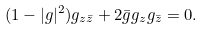Convert formula to latex. <formula><loc_0><loc_0><loc_500><loc_500>( 1 - | g | ^ { 2 } ) g _ { z \bar { z } } + 2 \bar { g } g _ { z } g _ { \bar { z } } = 0 .</formula> 